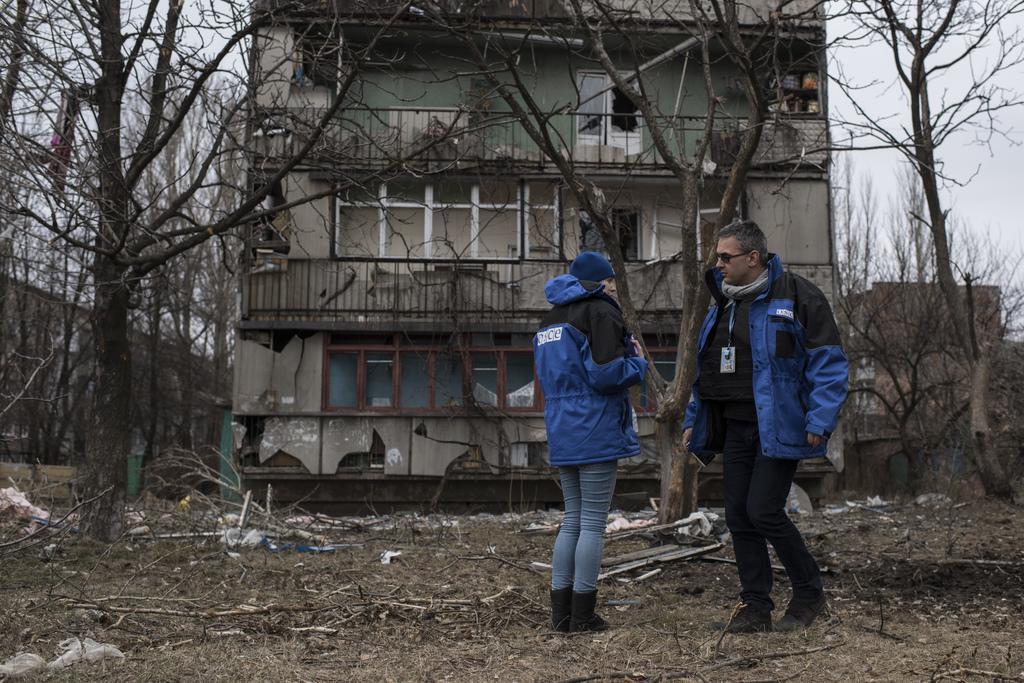In one or two sentences, can you explain what this image depicts? In this picture I can see a building and few trees and couple of them standing and I can see a cloudy sky and a man wore a ID card and I can see few sticks and grass on the ground. 